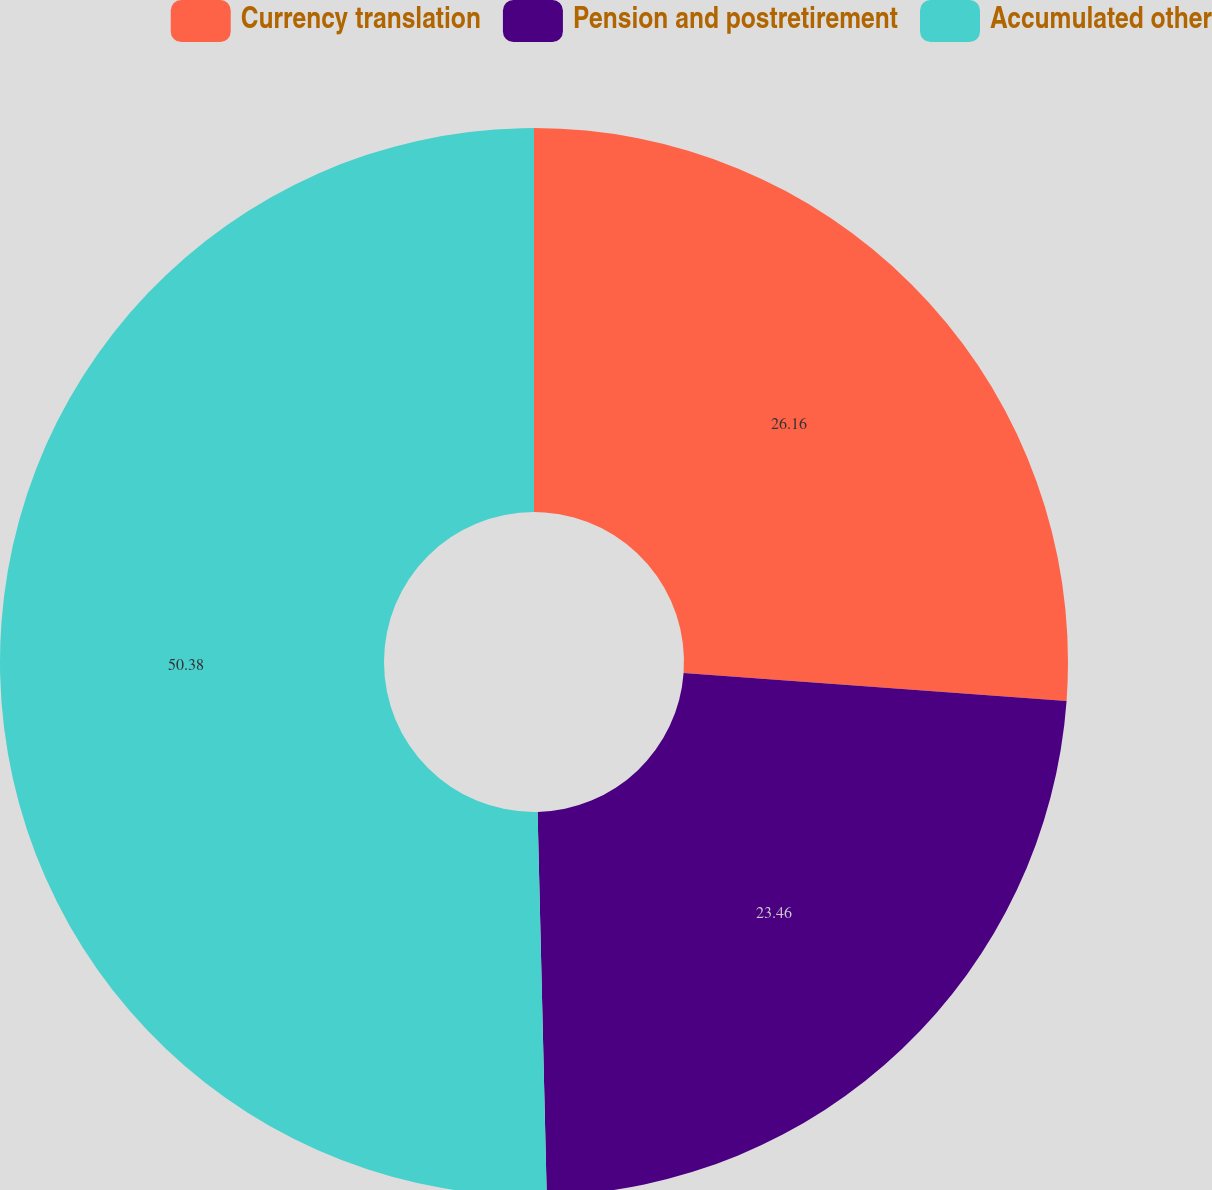Convert chart. <chart><loc_0><loc_0><loc_500><loc_500><pie_chart><fcel>Currency translation<fcel>Pension and postretirement<fcel>Accumulated other<nl><fcel>26.16%<fcel>23.46%<fcel>50.38%<nl></chart> 